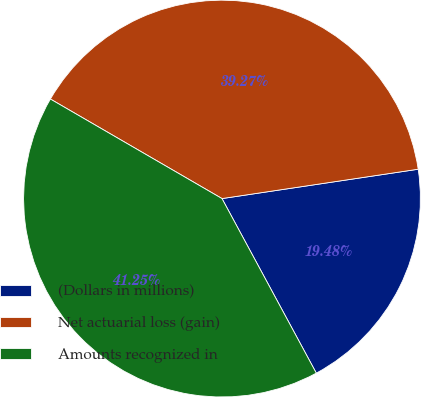<chart> <loc_0><loc_0><loc_500><loc_500><pie_chart><fcel>(Dollars in millions)<fcel>Net actuarial loss (gain)<fcel>Amounts recognized in<nl><fcel>19.48%<fcel>39.27%<fcel>41.25%<nl></chart> 